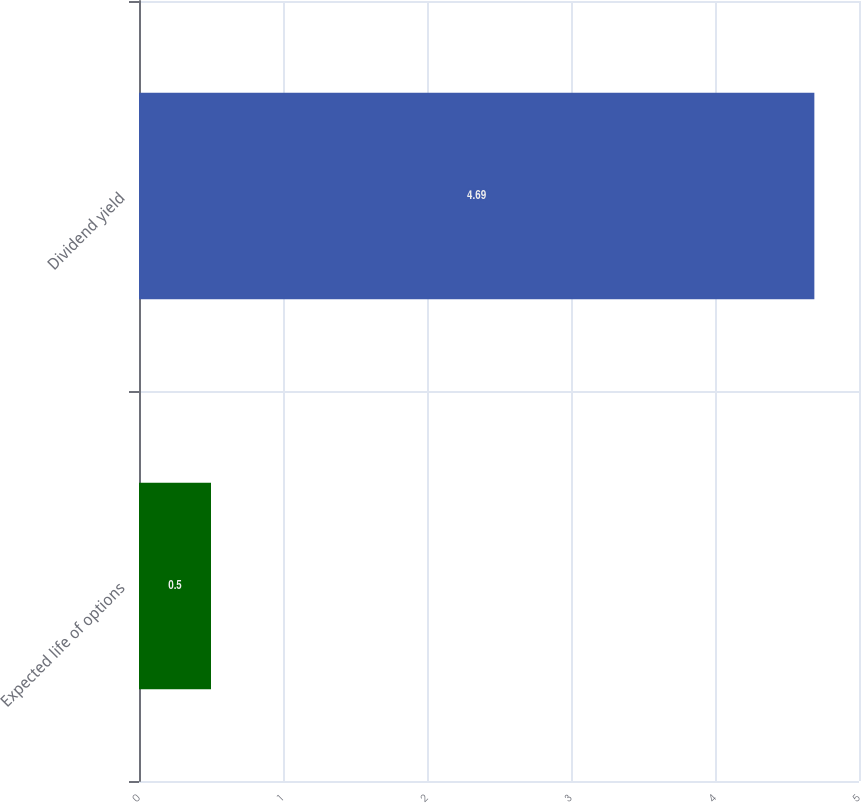Convert chart to OTSL. <chart><loc_0><loc_0><loc_500><loc_500><bar_chart><fcel>Expected life of options<fcel>Dividend yield<nl><fcel>0.5<fcel>4.69<nl></chart> 